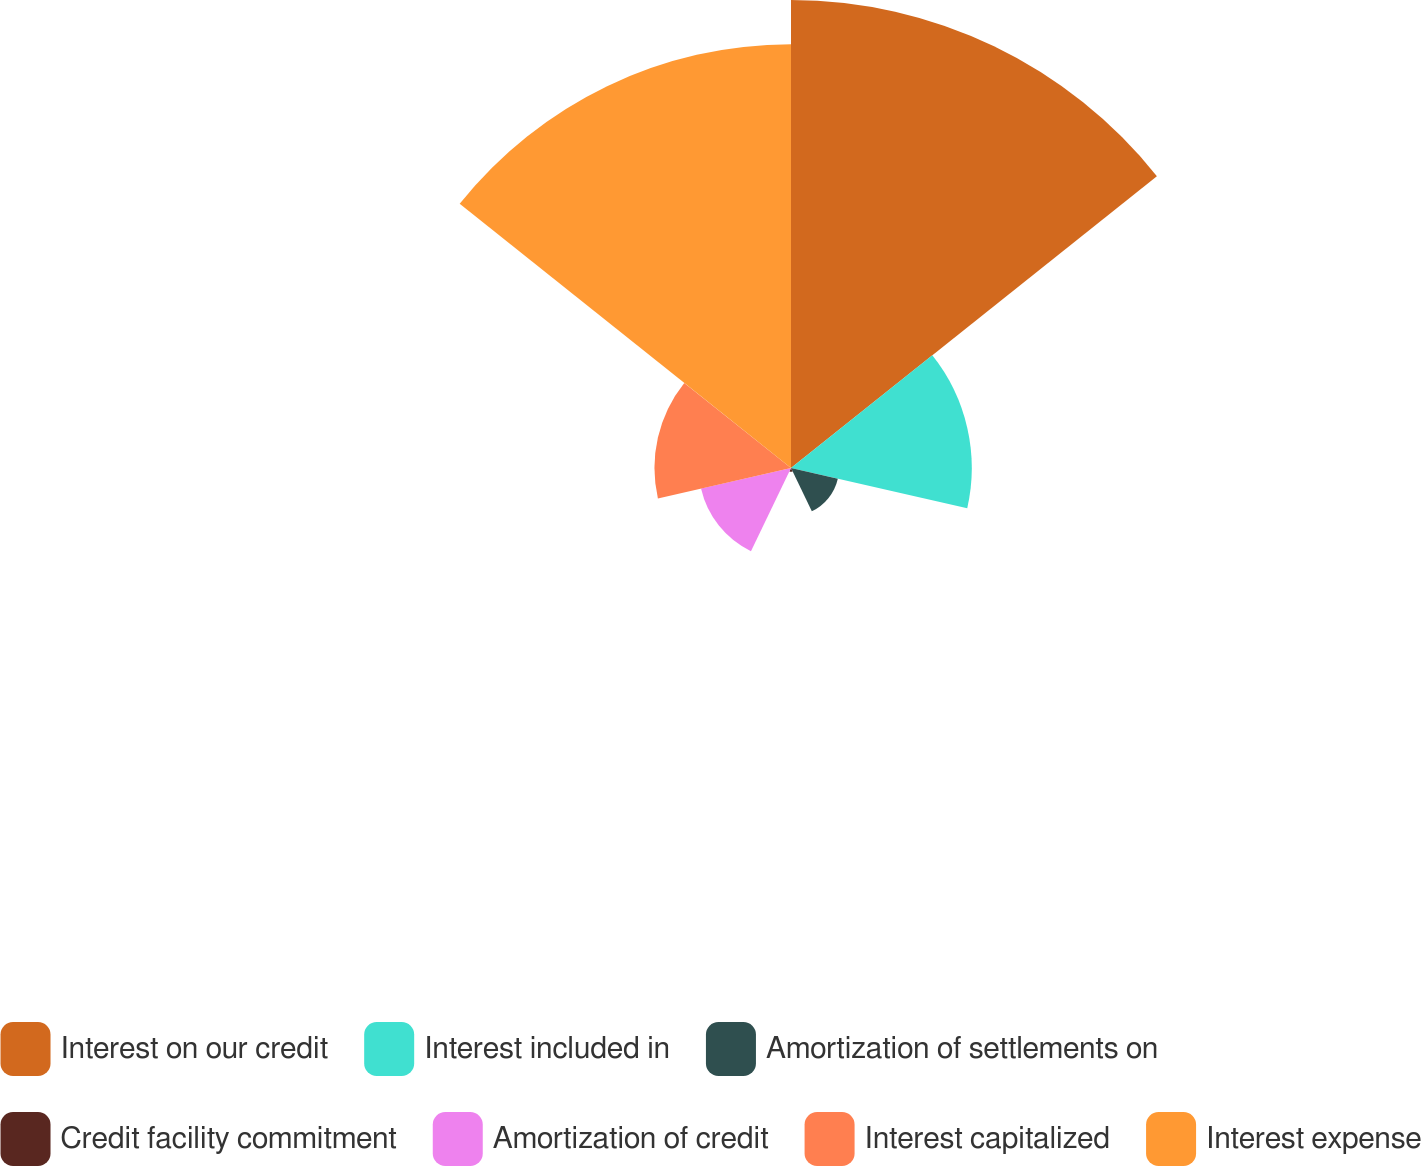Convert chart. <chart><loc_0><loc_0><loc_500><loc_500><pie_chart><fcel>Interest on our credit<fcel>Interest included in<fcel>Amortization of settlements on<fcel>Credit facility commitment<fcel>Amortization of credit<fcel>Interest capitalized<fcel>Interest expense<nl><fcel>34.59%<fcel>13.36%<fcel>3.55%<fcel>0.28%<fcel>6.82%<fcel>10.09%<fcel>31.32%<nl></chart> 